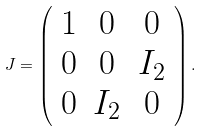<formula> <loc_0><loc_0><loc_500><loc_500>J = \left ( \begin{array} { c c c } 1 & 0 & 0 \\ 0 & 0 & I _ { 2 } \\ 0 & I _ { 2 } & 0 \end{array} \right ) .</formula> 